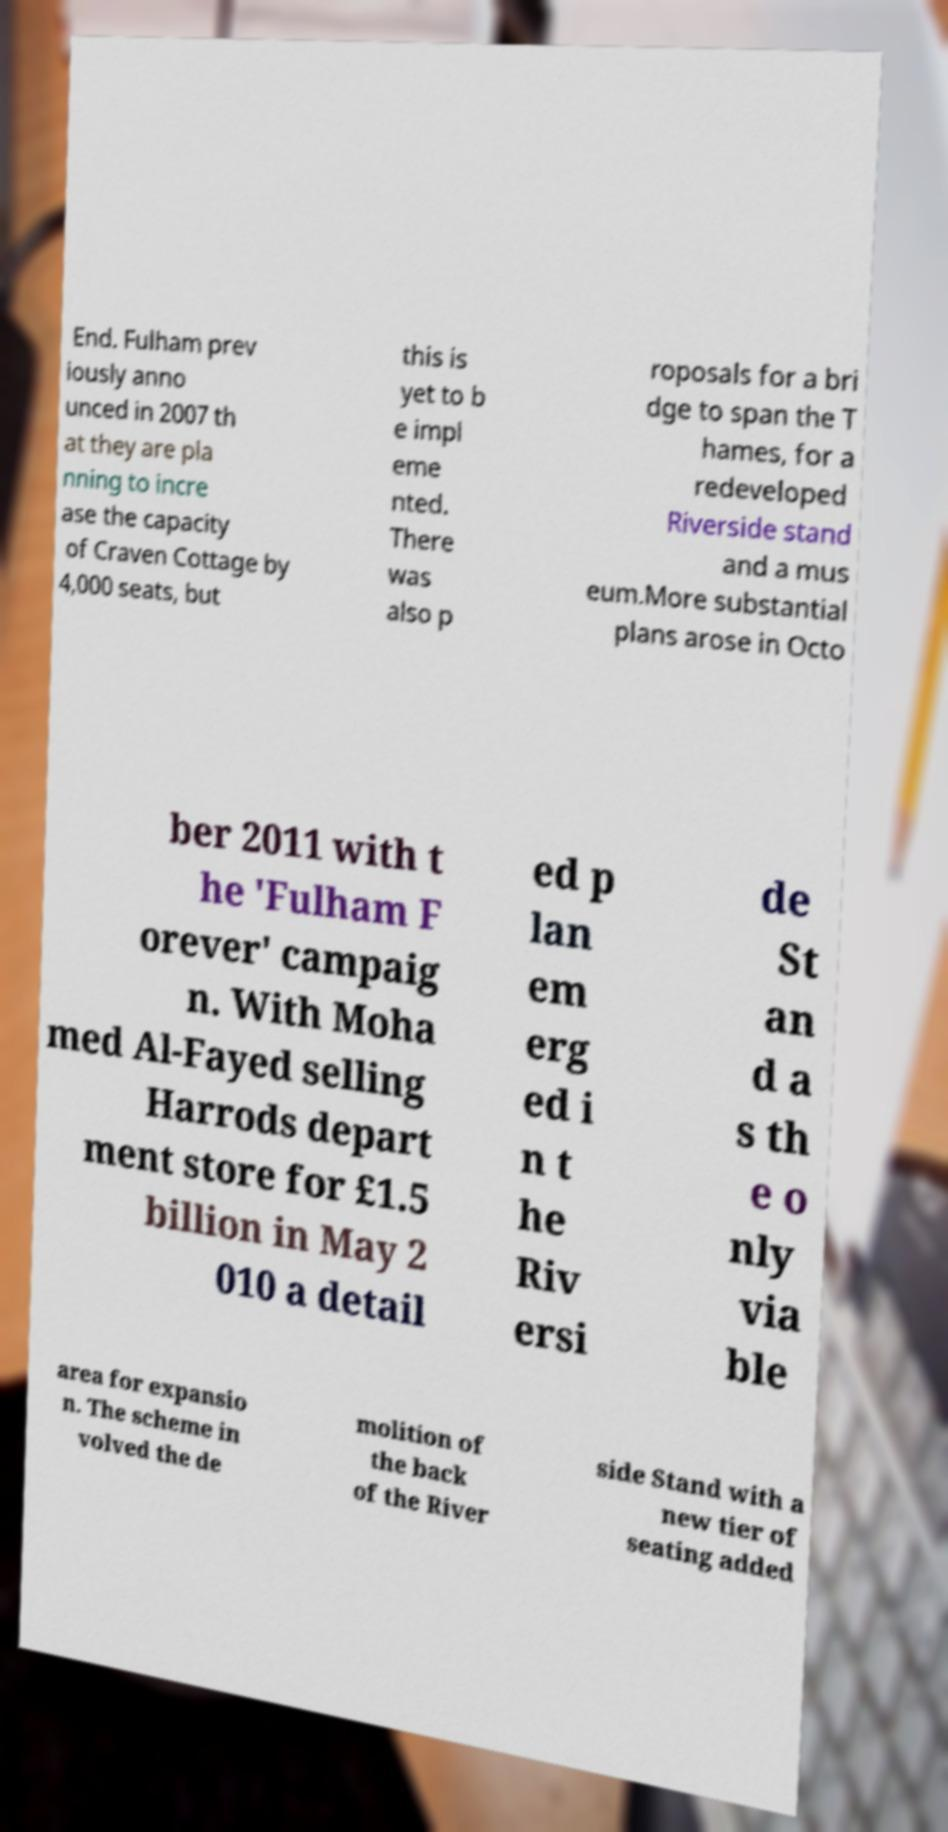Could you extract and type out the text from this image? End. Fulham prev iously anno unced in 2007 th at they are pla nning to incre ase the capacity of Craven Cottage by 4,000 seats, but this is yet to b e impl eme nted. There was also p roposals for a bri dge to span the T hames, for a redeveloped Riverside stand and a mus eum.More substantial plans arose in Octo ber 2011 with t he 'Fulham F orever' campaig n. With Moha med Al-Fayed selling Harrods depart ment store for £1.5 billion in May 2 010 a detail ed p lan em erg ed i n t he Riv ersi de St an d a s th e o nly via ble area for expansio n. The scheme in volved the de molition of the back of the River side Stand with a new tier of seating added 